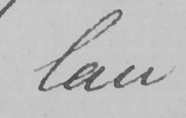Transcribe the text shown in this historical manuscript line. law 